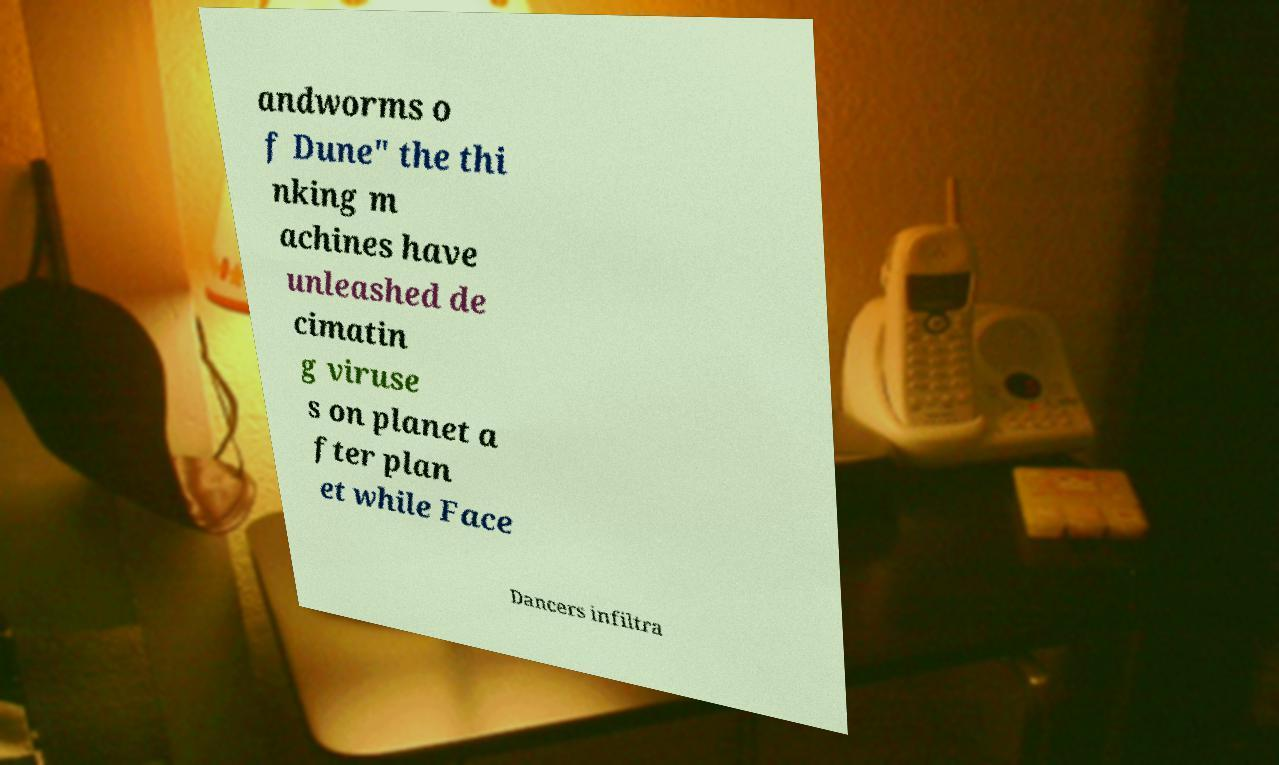I need the written content from this picture converted into text. Can you do that? andworms o f Dune" the thi nking m achines have unleashed de cimatin g viruse s on planet a fter plan et while Face Dancers infiltra 